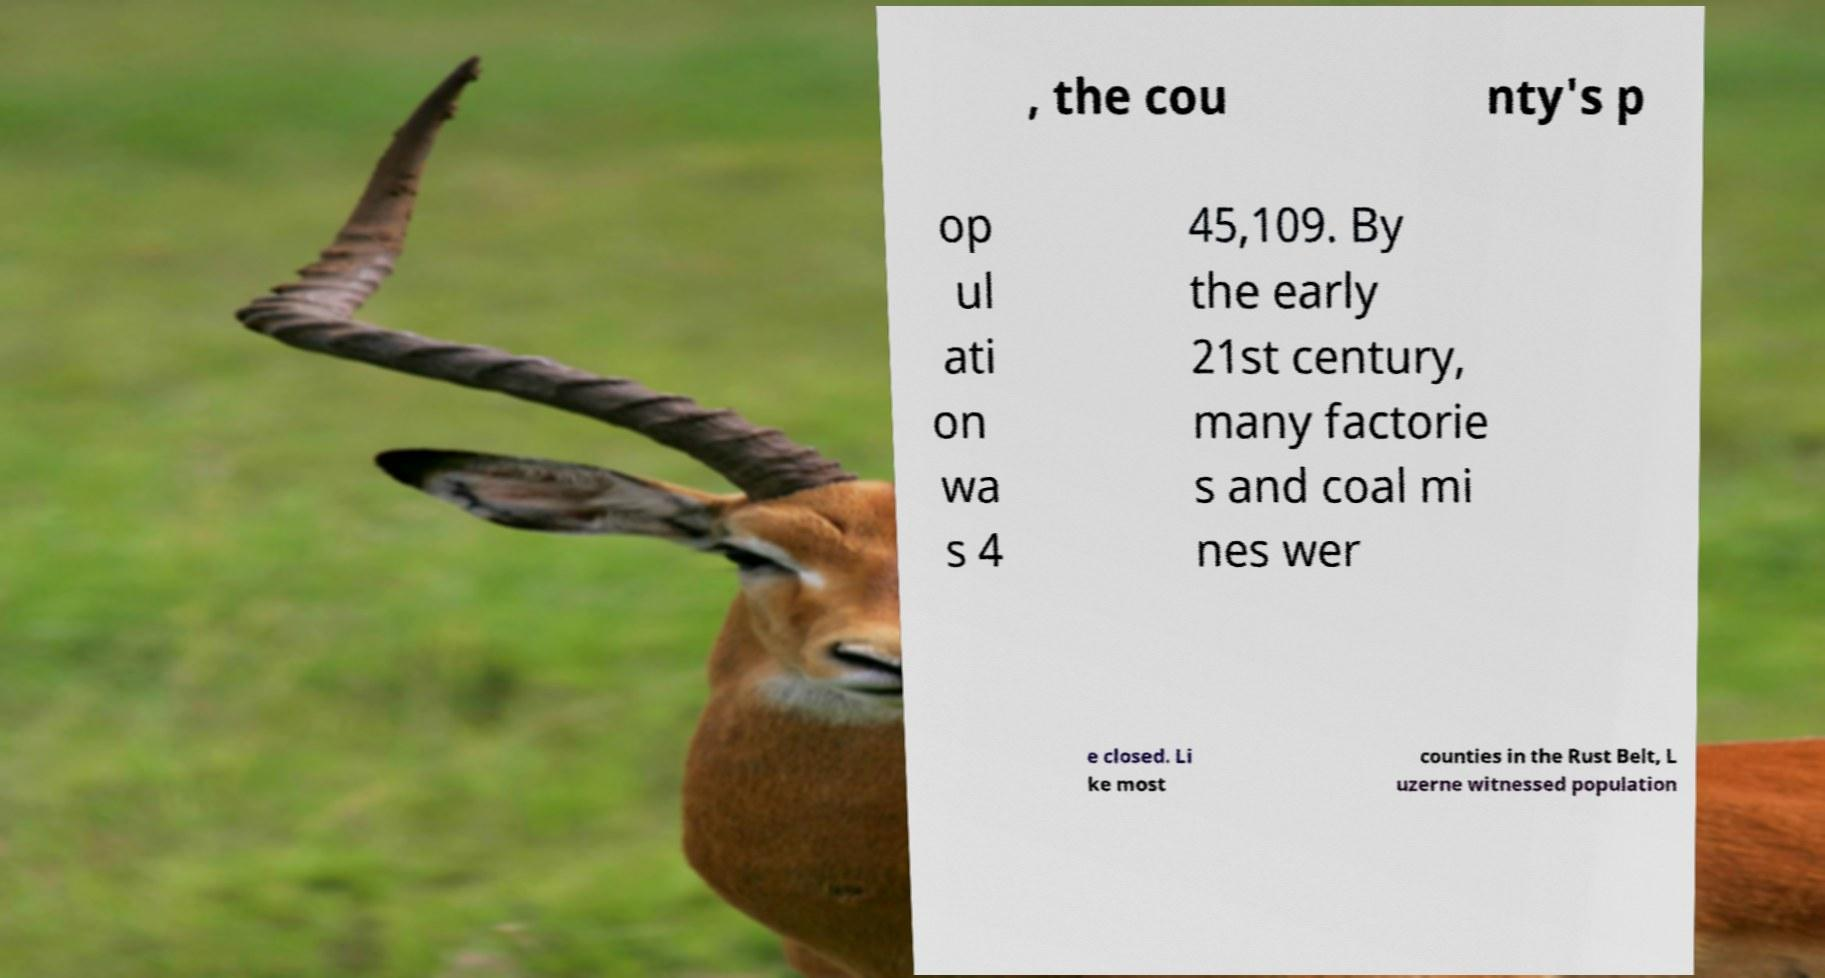Can you accurately transcribe the text from the provided image for me? , the cou nty's p op ul ati on wa s 4 45,109. By the early 21st century, many factorie s and coal mi nes wer e closed. Li ke most counties in the Rust Belt, L uzerne witnessed population 